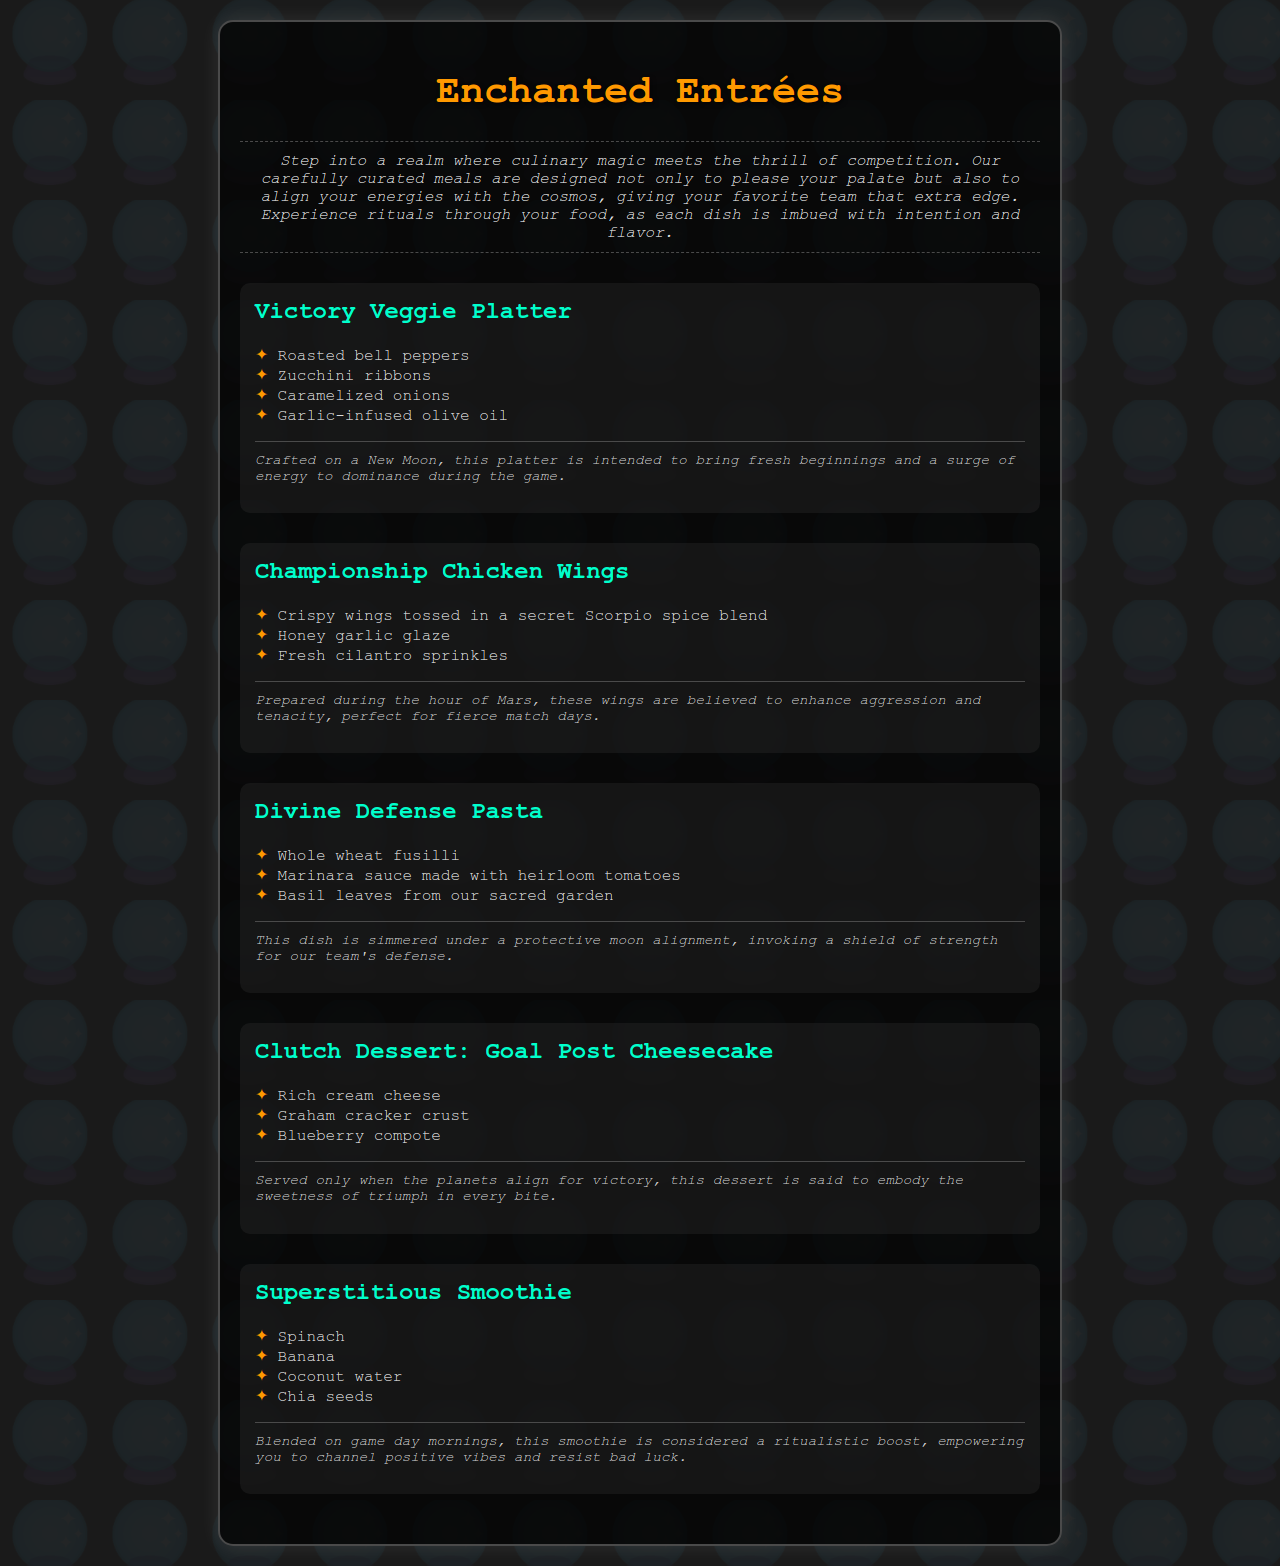What is the title of the restaurant menu? The title is prominently displayed at the top of the document, introducing the themed meals offered at the restaurant.
Answer: Enchanted Entrées What is the key ingredient of the Championship Chicken Wings? The main dish components are listed, with the key ingredient being highlighted as part of the description.
Answer: secret Scorpio spice blend When is the Victory Veggie Platter crafted? Specific moments for crafting each dish are mentioned in their respective rituals to emphasize their magical properties.
Answer: New Moon What type of cheese is used in the Goal Post Cheesecake? The ingredients list outlines the main components of the dessert, which includes a specific type of cheese.
Answer: cream cheese What is the significance of the Superstitious Smoothie? The description of the Superstitious Smoothie highlights its intended purpose and magical benefits on game day.
Answer: ritualistic boost Which dish is simmered under a protective moon alignment? The document details rituals associated with each dish, clearly indicating which dish has this preparation element.
Answer: Divine Defense Pasta How many dishes are included in the Enchanted Entrées menu? The number of different menu items can be counted from the list provided.
Answer: Five What garnish is used on the Championship Chicken Wings? The ingredients list specifies a fresh herb that enhances the wings' presentation and flavor.
Answer: Fresh cilantro sprinkles What is the last dish on the menu? The menu is organized sequentially, allowing for easy identification of the last item listed.
Answer: Superstitious Smoothie 